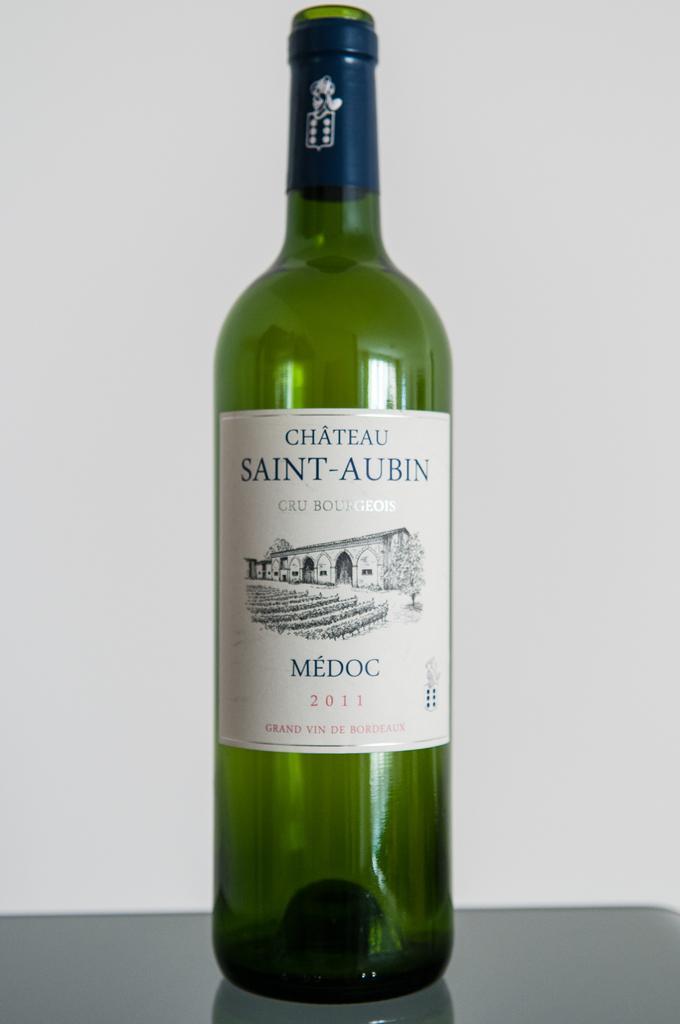Describe this image in one or two sentences. In this image there is a green colour bottle having a label. 